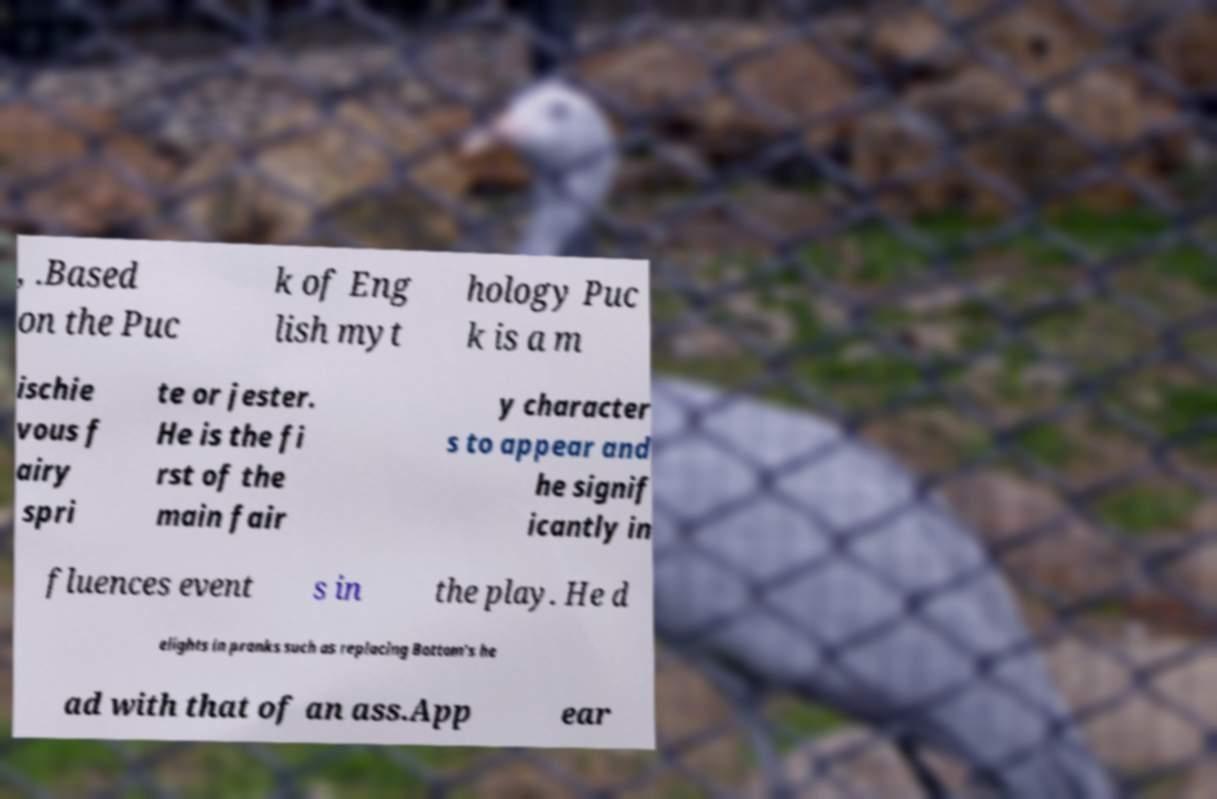Can you read and provide the text displayed in the image?This photo seems to have some interesting text. Can you extract and type it out for me? , .Based on the Puc k of Eng lish myt hology Puc k is a m ischie vous f airy spri te or jester. He is the fi rst of the main fair y character s to appear and he signif icantly in fluences event s in the play. He d elights in pranks such as replacing Bottom's he ad with that of an ass.App ear 